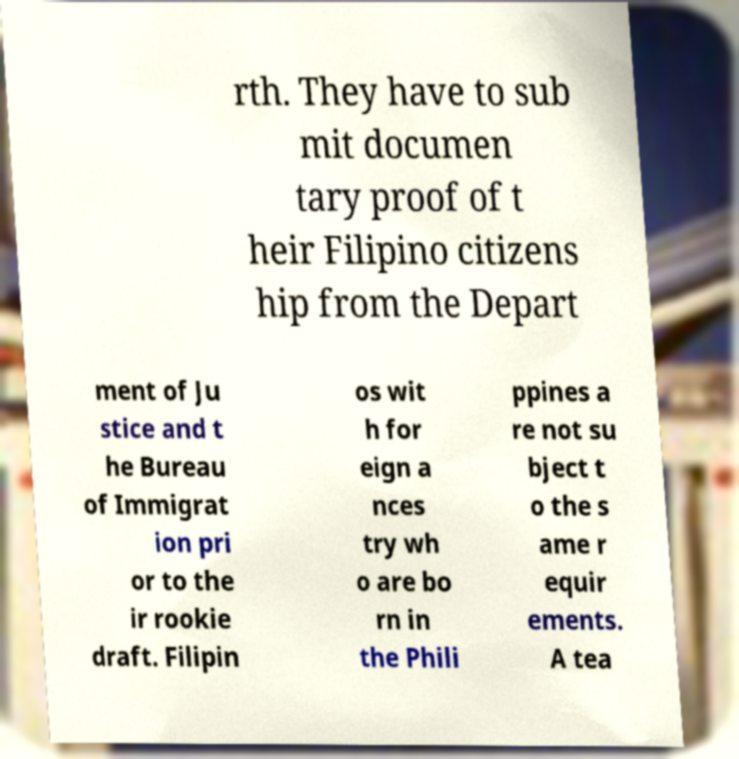Can you read and provide the text displayed in the image?This photo seems to have some interesting text. Can you extract and type it out for me? rth. They have to sub mit documen tary proof of t heir Filipino citizens hip from the Depart ment of Ju stice and t he Bureau of Immigrat ion pri or to the ir rookie draft. Filipin os wit h for eign a nces try wh o are bo rn in the Phili ppines a re not su bject t o the s ame r equir ements. A tea 